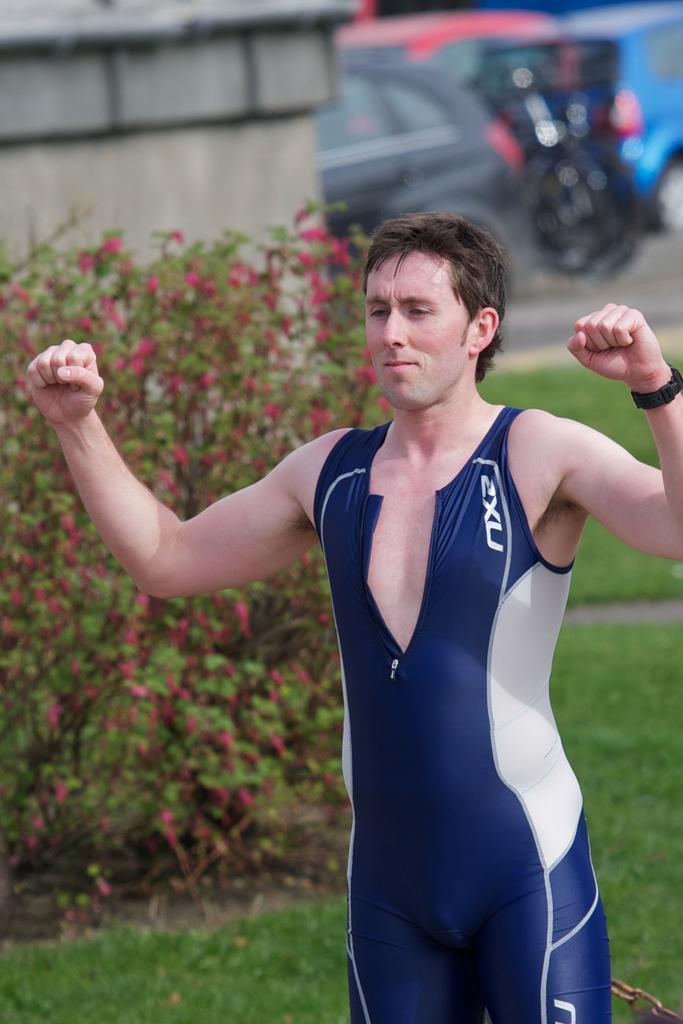Can you describe this image briefly? In this image in the front there is a person standing. In the background there are flowers, there is grass on the ground, there is a wall and there are vehicles. 